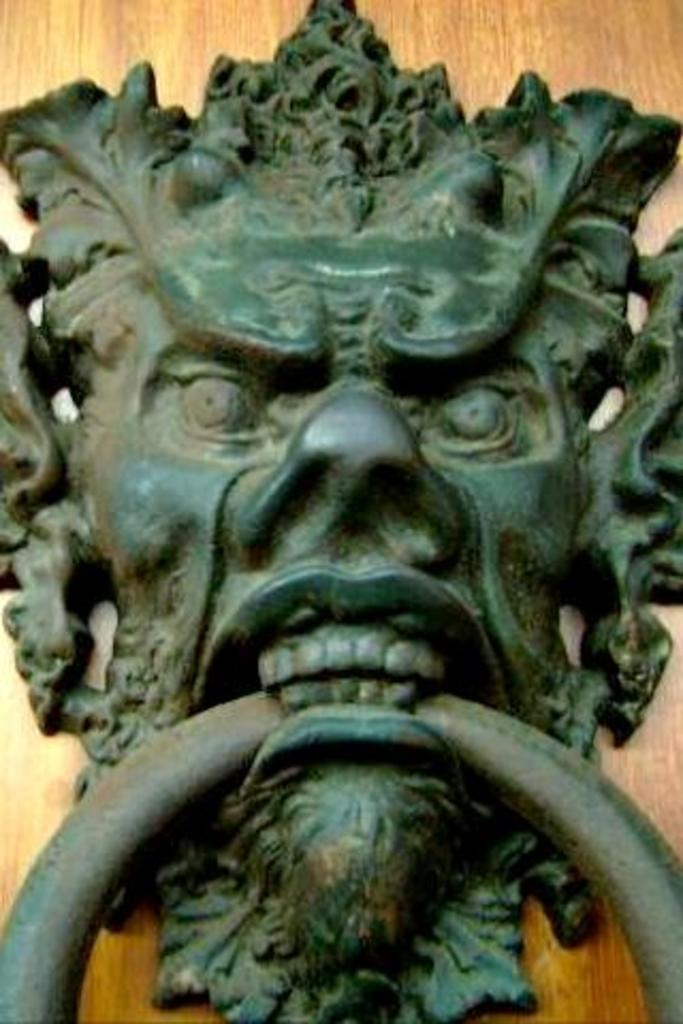What is the main object in the image? There is a door knocker in the image. What material is the object the door knocker is attached to? The door knocker is attached to a wooden object. How many airplanes are visible in the image? There are no airplanes visible in the image; it only features a door knocker and a wooden object. What time of day is depicted in the image? The provided facts do not give any information about the time of day, so it cannot be determined from the image. 